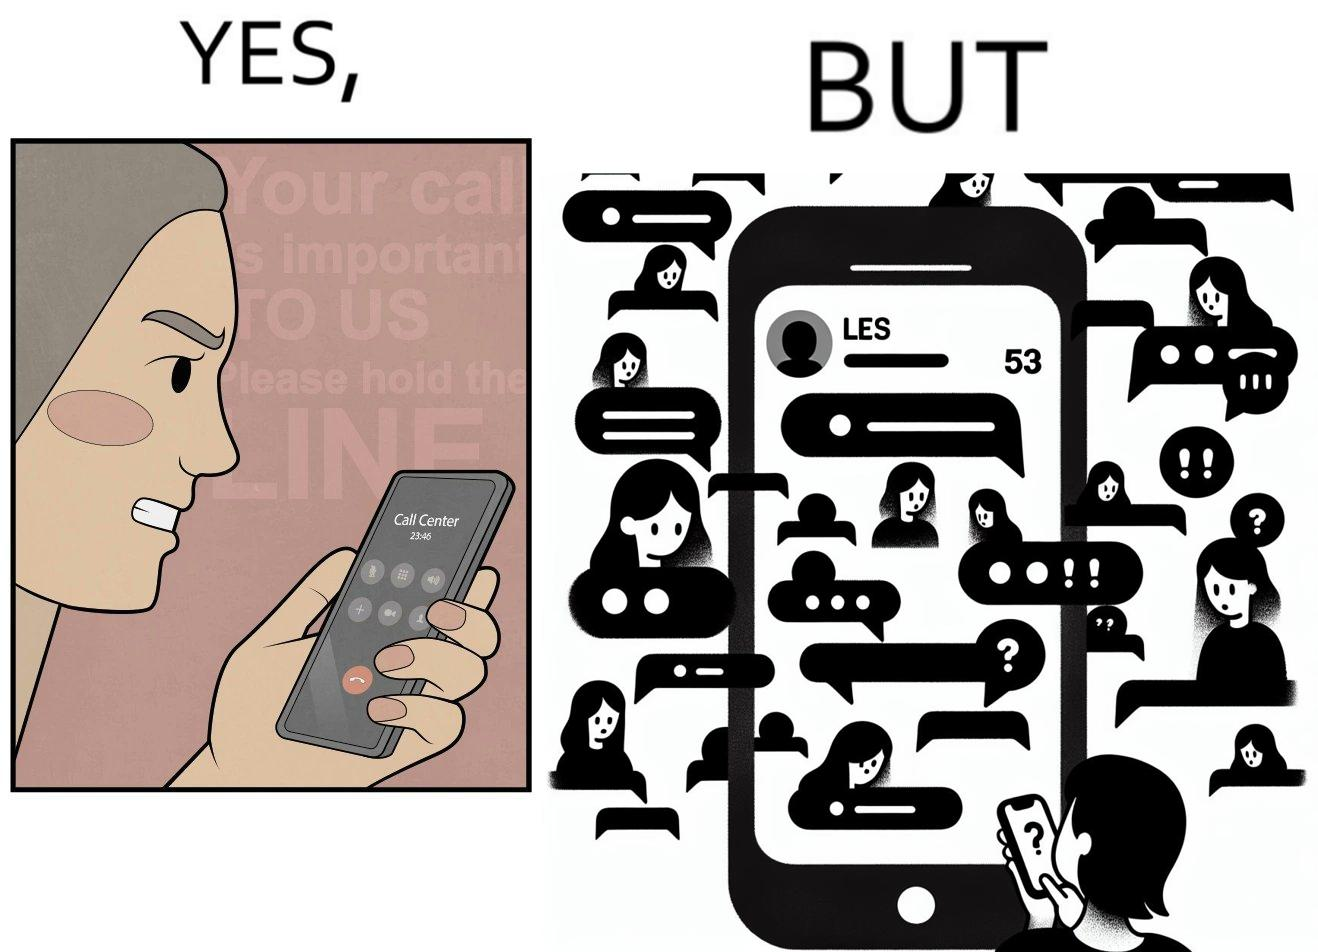Describe the contrast between the left and right parts of this image. In the left part of the image: The image shows an annoyed woman talking to the representative in the call center on her mobile phone for over 23 minutes and 45 seconds. In the right part of the image: The image shows the chats of a person on their phone. There are a total of 53 unread chats. In the unanswered chats, the people on the other end are asking if this person got their message or if this person is ignoring them. 